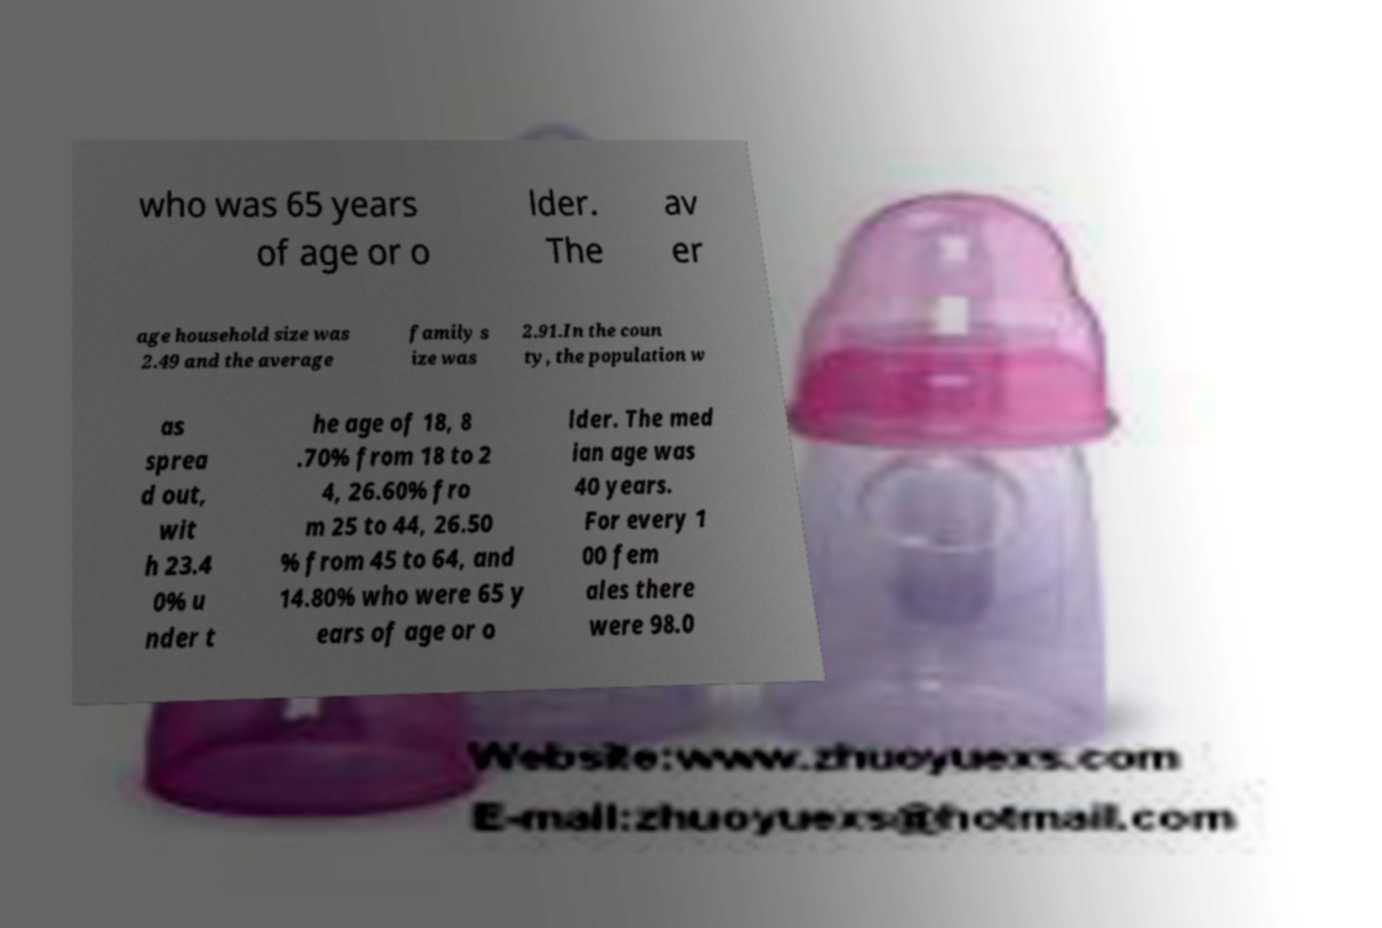There's text embedded in this image that I need extracted. Can you transcribe it verbatim? who was 65 years of age or o lder. The av er age household size was 2.49 and the average family s ize was 2.91.In the coun ty, the population w as sprea d out, wit h 23.4 0% u nder t he age of 18, 8 .70% from 18 to 2 4, 26.60% fro m 25 to 44, 26.50 % from 45 to 64, and 14.80% who were 65 y ears of age or o lder. The med ian age was 40 years. For every 1 00 fem ales there were 98.0 